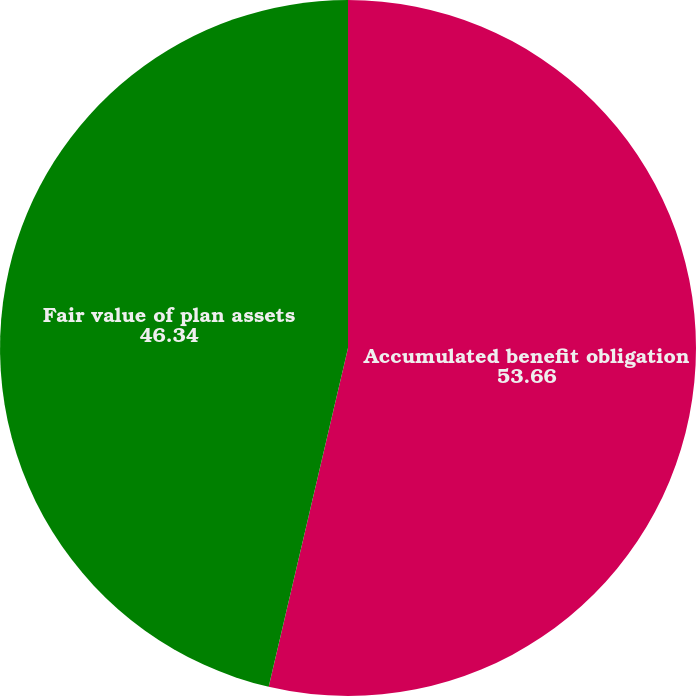<chart> <loc_0><loc_0><loc_500><loc_500><pie_chart><fcel>Accumulated benefit obligation<fcel>Fair value of plan assets<nl><fcel>53.66%<fcel>46.34%<nl></chart> 